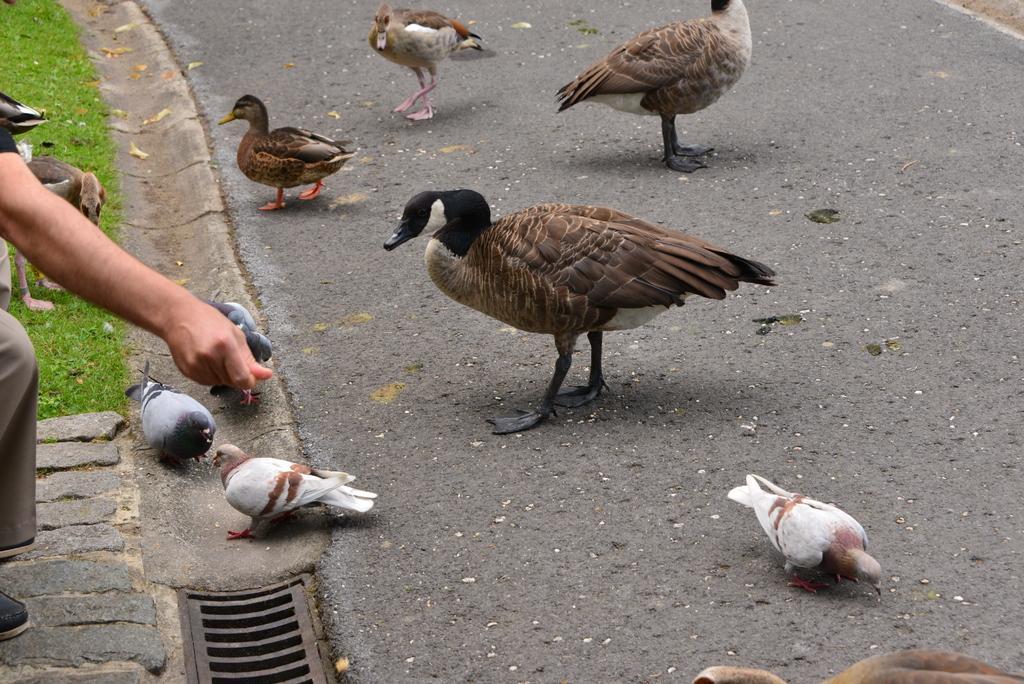Can you describe this image briefly? In this image we can see a group of birds on the road. On the left side we can see the hand of a person, a grill and some grass. 